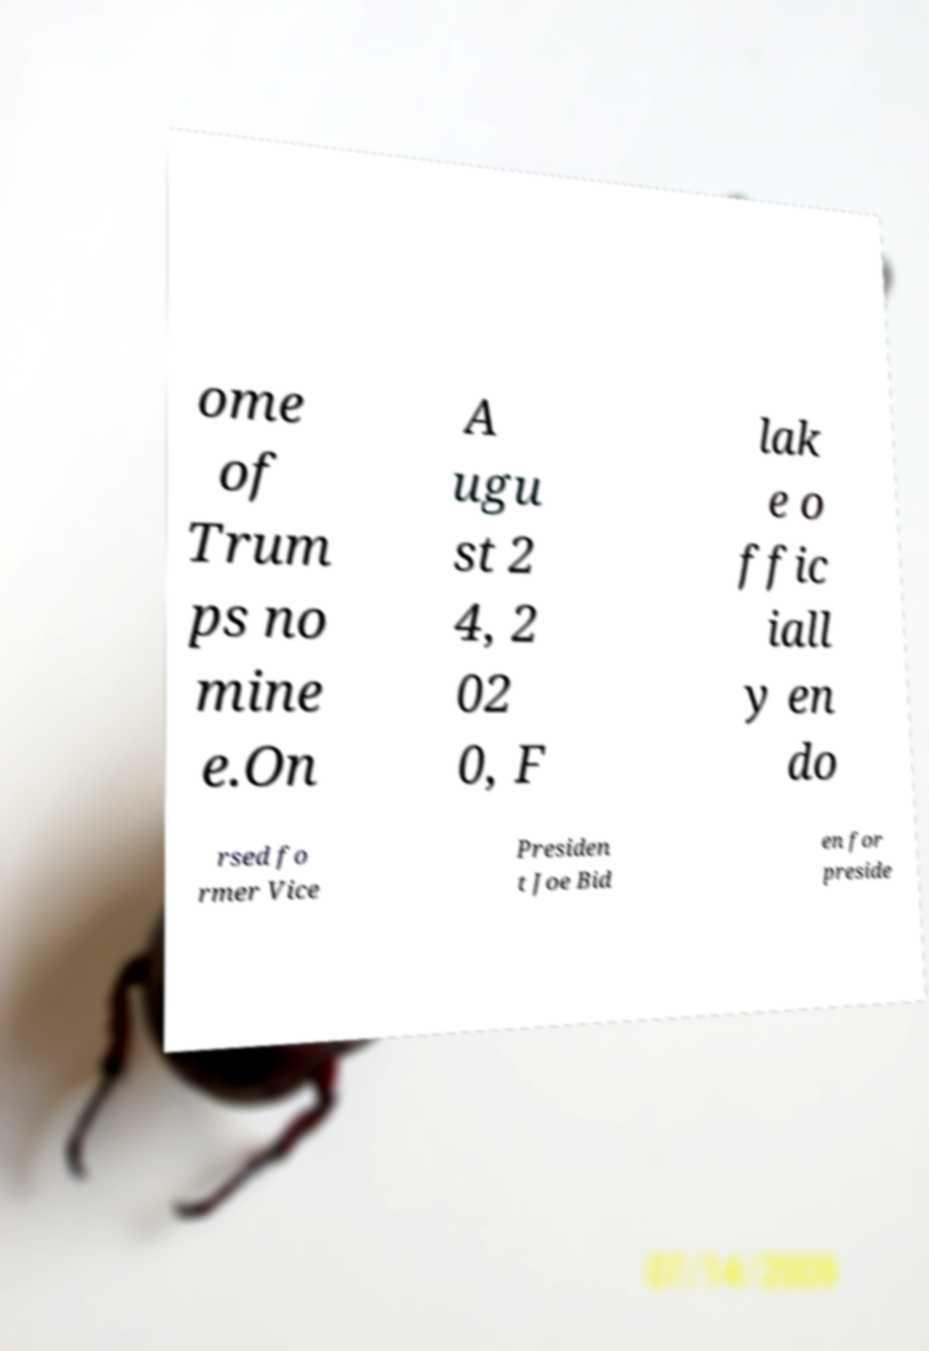Can you accurately transcribe the text from the provided image for me? ome of Trum ps no mine e.On A ugu st 2 4, 2 02 0, F lak e o ffic iall y en do rsed fo rmer Vice Presiden t Joe Bid en for preside 